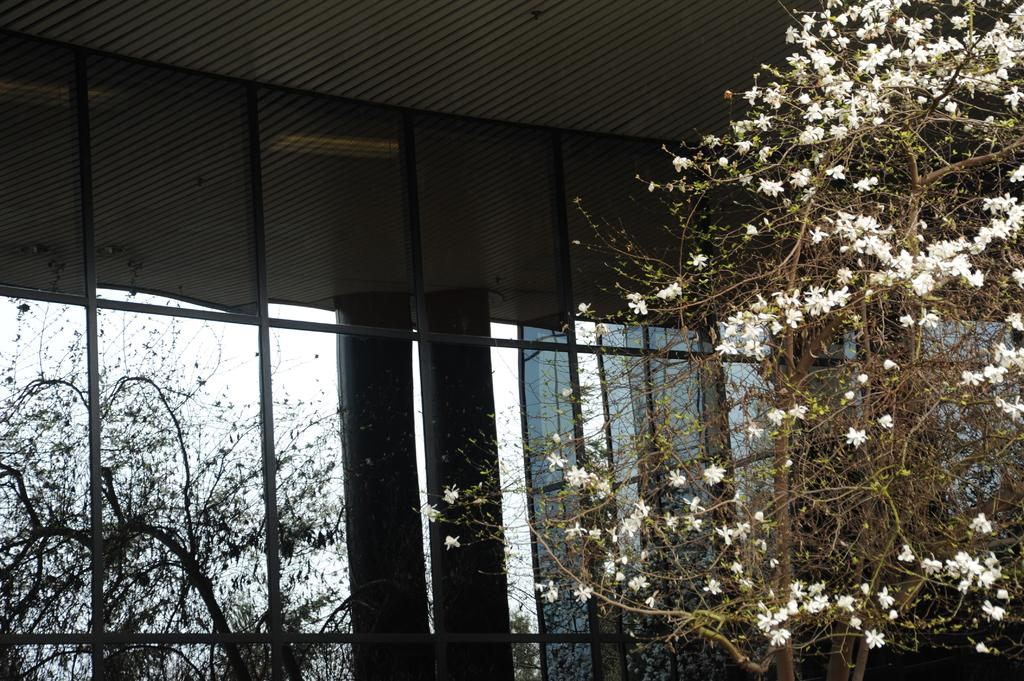What type of flowers can be seen on the plant in the image? There are white color flowers on a plant in the image. What structure is visible in the image? There is a shed visible in the image. What color is the sky in the background of the image? The sky appears white in the background of the image. What songs are being sung by the ghost in the image? There is no ghost or singing present in the image; it features white flowers on a plant, a shed, and a white sky in the background. 